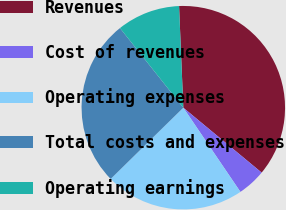Convert chart. <chart><loc_0><loc_0><loc_500><loc_500><pie_chart><fcel>Revenues<fcel>Cost of revenues<fcel>Operating expenses<fcel>Total costs and expenses<fcel>Operating earnings<nl><fcel>36.68%<fcel>4.5%<fcel>22.14%<fcel>26.65%<fcel>10.03%<nl></chart> 